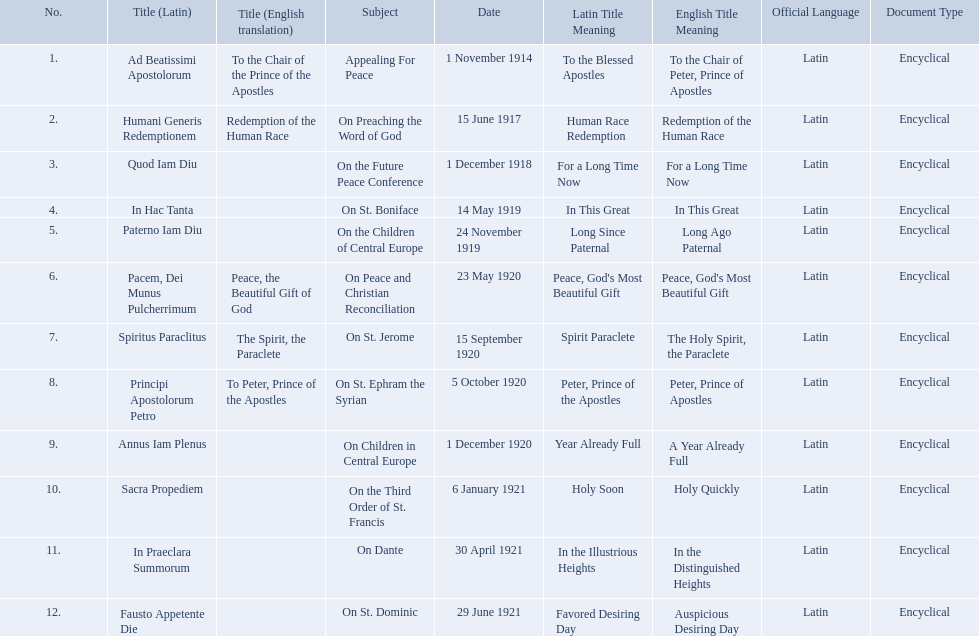Parse the full table. {'header': ['No.', 'Title (Latin)', 'Title (English translation)', 'Subject', 'Date', 'Latin Title Meaning', 'English Title Meaning', 'Official Language', 'Document Type'], 'rows': [['1.', 'Ad Beatissimi Apostolorum', 'To the Chair of the Prince of the Apostles', 'Appealing For Peace', '1 November 1914', 'To the Blessed Apostles', 'To the Chair of Peter, Prince of Apostles', 'Latin', 'Encyclical'], ['2.', 'Humani Generis Redemptionem', 'Redemption of the Human Race', 'On Preaching the Word of God', '15 June 1917', 'Human Race Redemption', 'Redemption of the Human Race', 'Latin', 'Encyclical'], ['3.', 'Quod Iam Diu', '', 'On the Future Peace Conference', '1 December 1918', 'For a Long Time Now', 'For a Long Time Now', 'Latin', 'Encyclical'], ['4.', 'In Hac Tanta', '', 'On St. Boniface', '14 May 1919', 'In This Great', 'In This Great', 'Latin', 'Encyclical'], ['5.', 'Paterno Iam Diu', '', 'On the Children of Central Europe', '24 November 1919', 'Long Since Paternal', 'Long Ago Paternal', 'Latin', 'Encyclical'], ['6.', 'Pacem, Dei Munus Pulcherrimum', 'Peace, the Beautiful Gift of God', 'On Peace and Christian Reconciliation', '23 May 1920', "Peace, God's Most Beautiful Gift", "Peace, God's Most Beautiful Gift", 'Latin', 'Encyclical'], ['7.', 'Spiritus Paraclitus', 'The Spirit, the Paraclete', 'On St. Jerome', '15 September 1920', 'Spirit Paraclete', 'The Holy Spirit, the Paraclete', 'Latin', 'Encyclical'], ['8.', 'Principi Apostolorum Petro', 'To Peter, Prince of the Apostles', 'On St. Ephram the Syrian', '5 October 1920', 'Peter, Prince of the Apostles', 'Peter, Prince of Apostles', 'Latin', 'Encyclical'], ['9.', 'Annus Iam Plenus', '', 'On Children in Central Europe', '1 December 1920', 'Year Already Full', 'A Year Already Full', 'Latin', 'Encyclical'], ['10.', 'Sacra Propediem', '', 'On the Third Order of St. Francis', '6 January 1921', 'Holy Soon', 'Holy Quickly', 'Latin', 'Encyclical'], ['11.', 'In Praeclara Summorum', '', 'On Dante', '30 April 1921', 'In the Illustrious Heights', 'In the Distinguished Heights', 'Latin', 'Encyclical'], ['12.', 'Fausto Appetente Die', '', 'On St. Dominic', '29 June 1921', 'Favored Desiring Day', 'Auspicious Desiring Day', 'Latin', 'Encyclical']]} What are all the subjects? Appealing For Peace, On Preaching the Word of God, On the Future Peace Conference, On St. Boniface, On the Children of Central Europe, On Peace and Christian Reconciliation, On St. Jerome, On St. Ephram the Syrian, On Children in Central Europe, On the Third Order of St. Francis, On Dante, On St. Dominic. What are their dates? 1 November 1914, 15 June 1917, 1 December 1918, 14 May 1919, 24 November 1919, 23 May 1920, 15 September 1920, 5 October 1920, 1 December 1920, 6 January 1921, 30 April 1921, 29 June 1921. Which subject's date belongs to 23 may 1920? On Peace and Christian Reconciliation. What are all the subjects? Appealing For Peace, On Preaching the Word of God, On the Future Peace Conference, On St. Boniface, On the Children of Central Europe, On Peace and Christian Reconciliation, On St. Jerome, On St. Ephram the Syrian, On Children in Central Europe, On the Third Order of St. Francis, On Dante, On St. Dominic. Which occurred in 1920? On Peace and Christian Reconciliation, On St. Jerome, On St. Ephram the Syrian, On Children in Central Europe. Which occurred in may of that year? On Peace and Christian Reconciliation. 